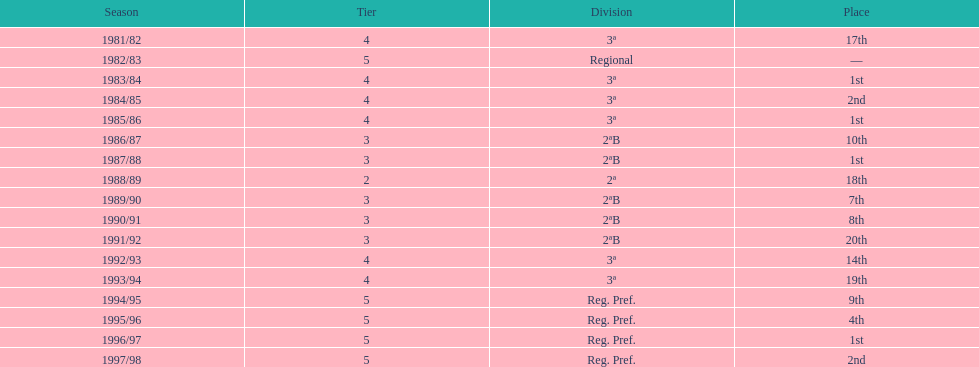How many times was the second place achieved? 2. 